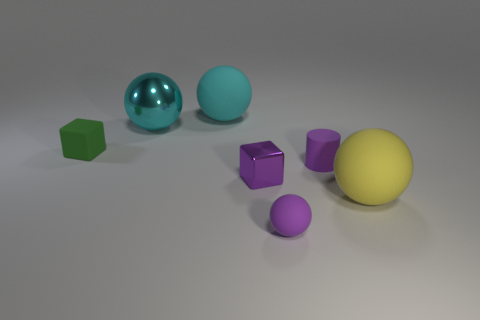Subtract all big yellow rubber balls. How many balls are left? 3 Subtract all yellow spheres. How many spheres are left? 3 Subtract 1 cylinders. How many cylinders are left? 0 Subtract all cubes. How many objects are left? 5 Add 1 large matte balls. How many large matte balls are left? 3 Add 2 large cyan rubber balls. How many large cyan rubber balls exist? 3 Add 2 tiny purple balls. How many objects exist? 9 Subtract 0 green cylinders. How many objects are left? 7 Subtract all gray cylinders. Subtract all gray cubes. How many cylinders are left? 1 Subtract all blue cylinders. How many yellow blocks are left? 0 